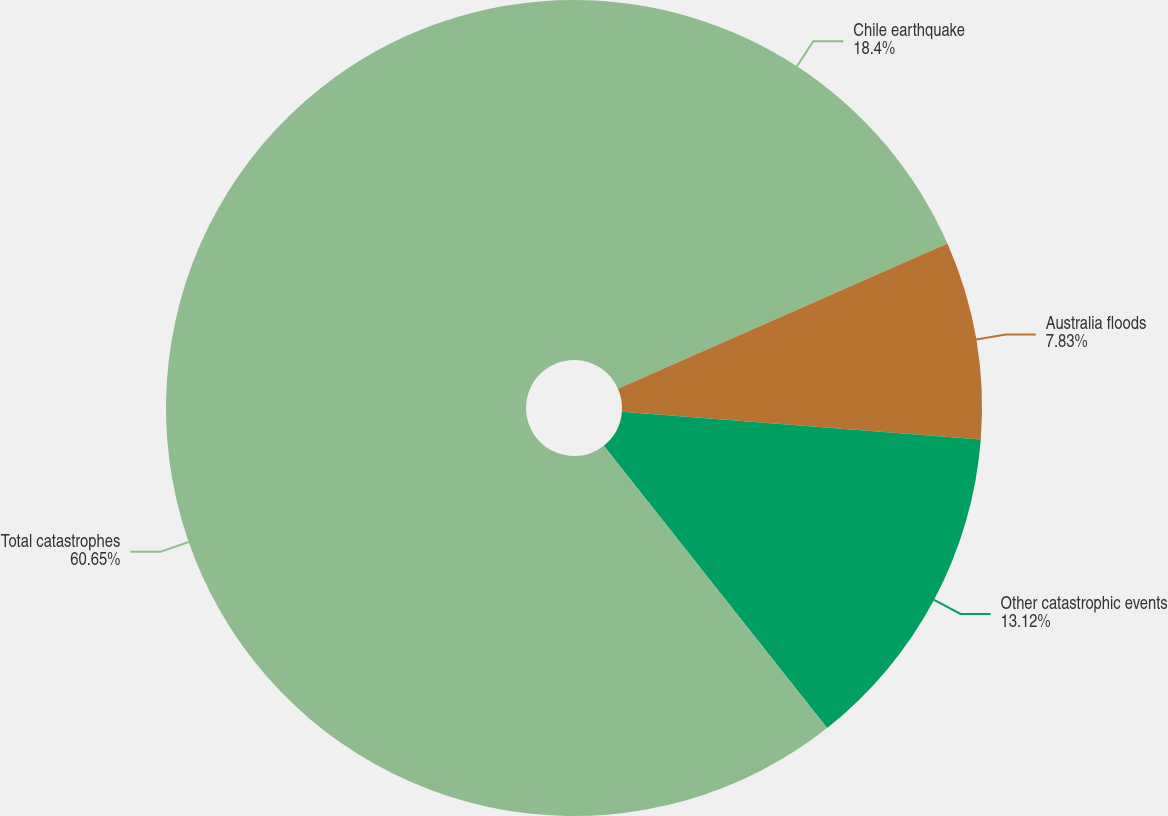Convert chart to OTSL. <chart><loc_0><loc_0><loc_500><loc_500><pie_chart><fcel>Chile earthquake<fcel>Australia floods<fcel>Other catastrophic events<fcel>Total catastrophes<nl><fcel>18.4%<fcel>7.83%<fcel>13.12%<fcel>60.65%<nl></chart> 